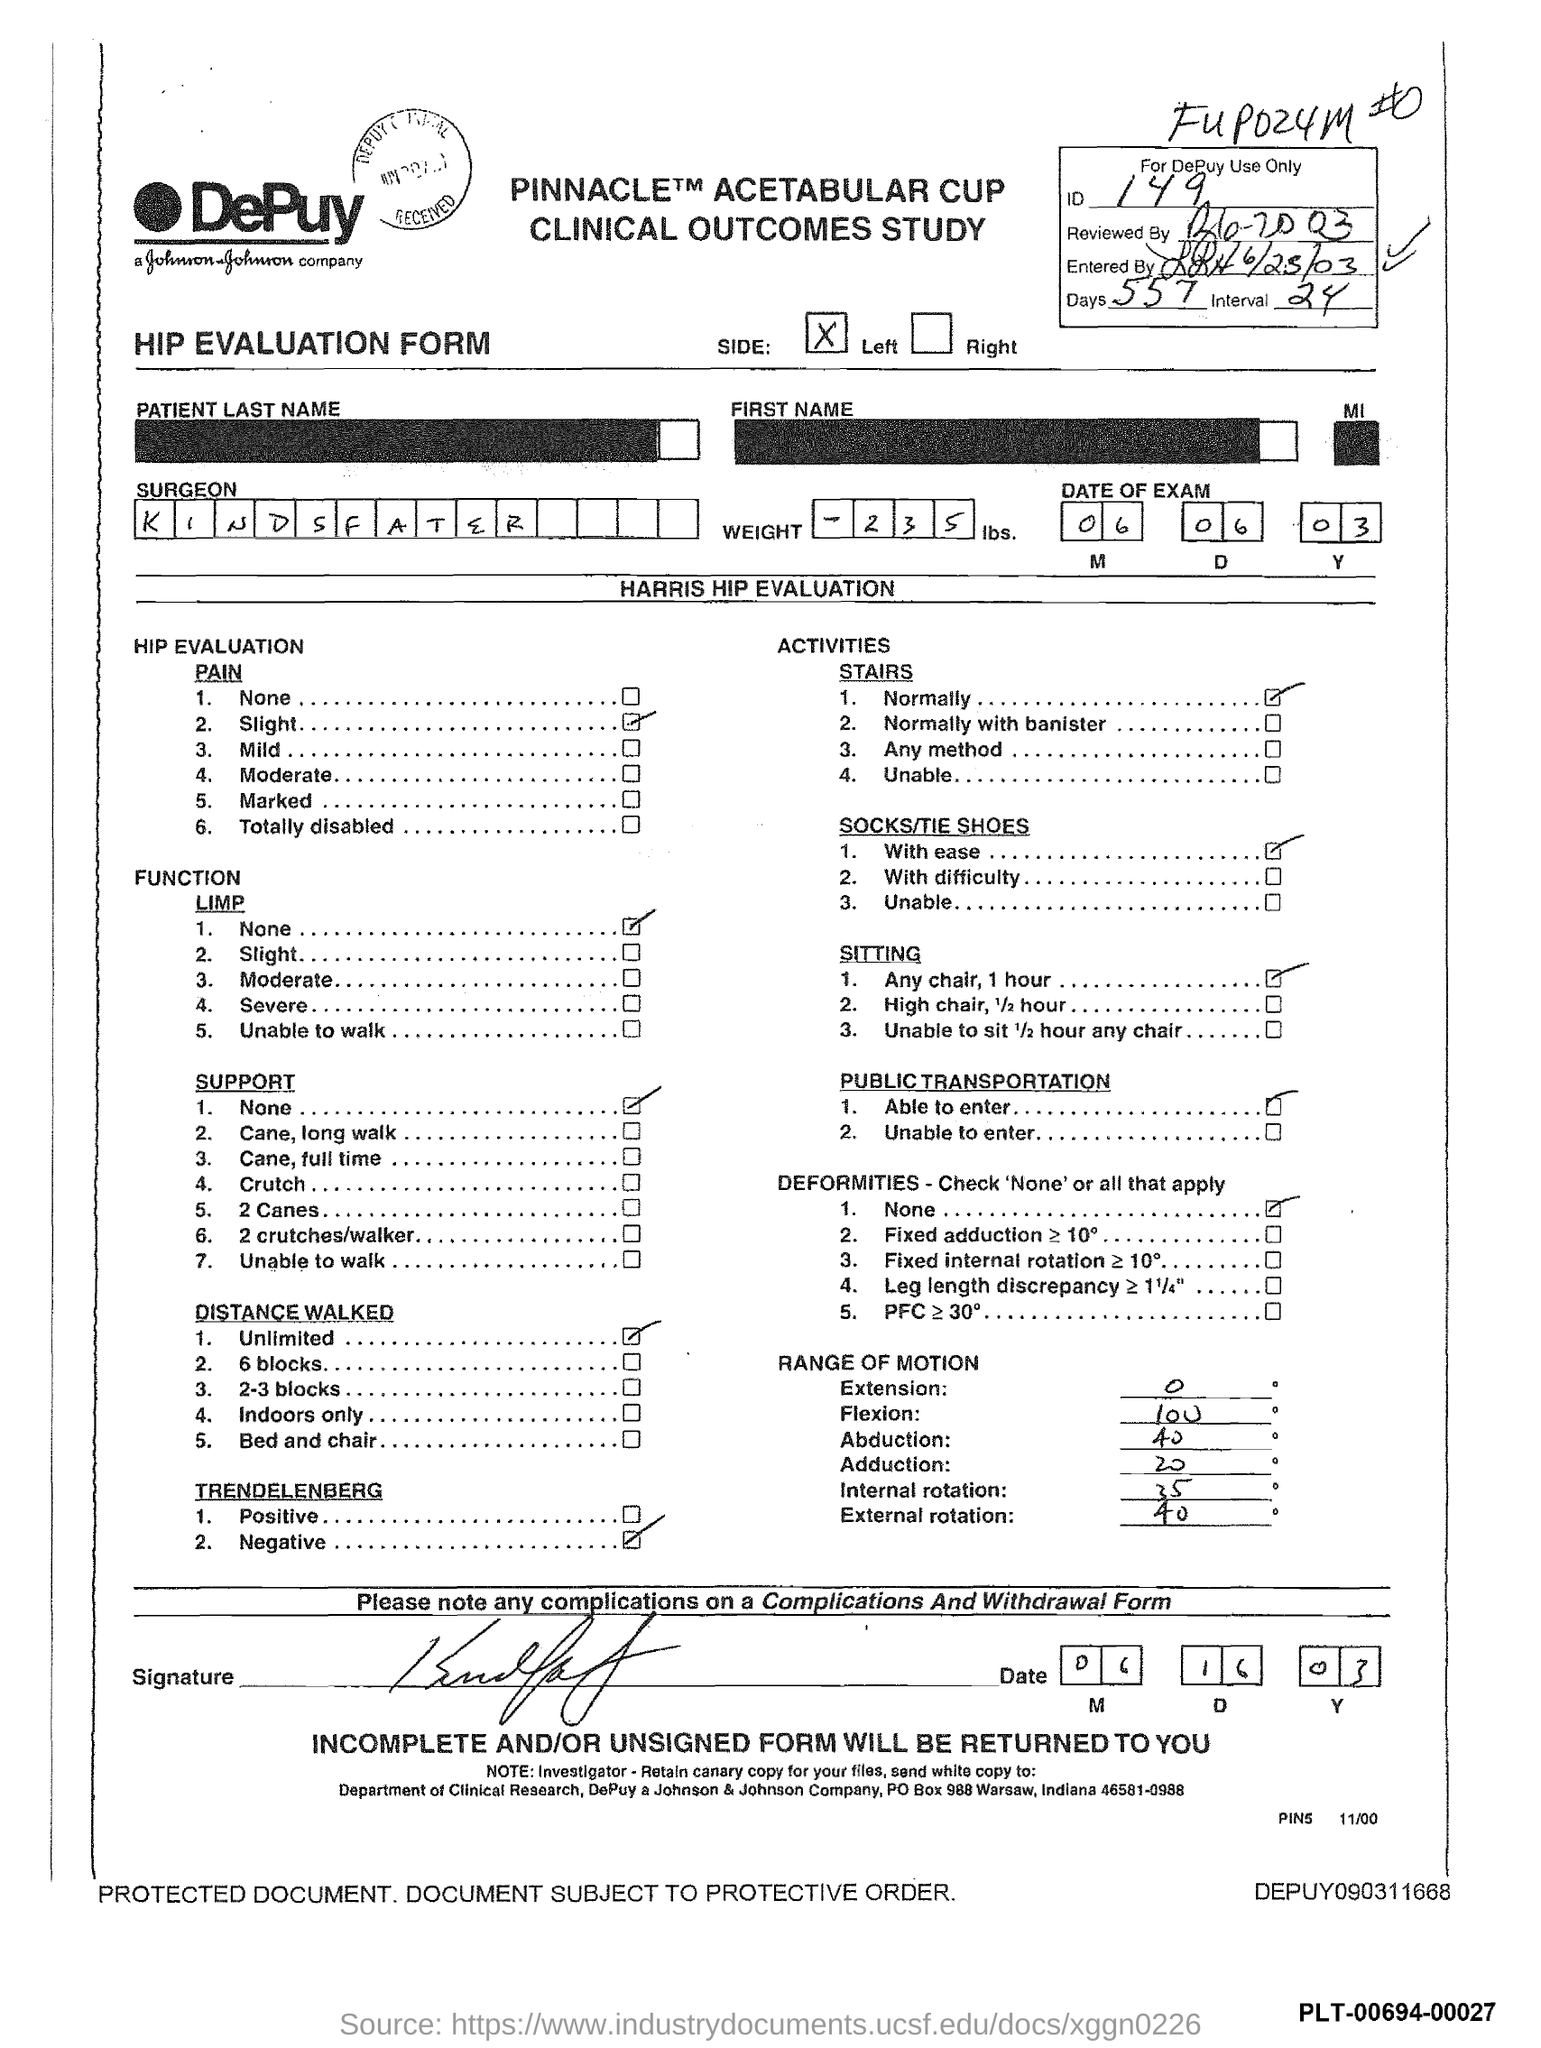What is the ID mentioned in the form?
Give a very brief answer. 149. What is the no of days given in the form?
Give a very brief answer. 557. What is the date of exam mentioned in the form?
Provide a succinct answer. 06.06.03. What is the surgeon name mentioned in the form?
Make the answer very short. KINDSFATER. What type of form is this?
Give a very brief answer. HIP EVALUATION FORM. 